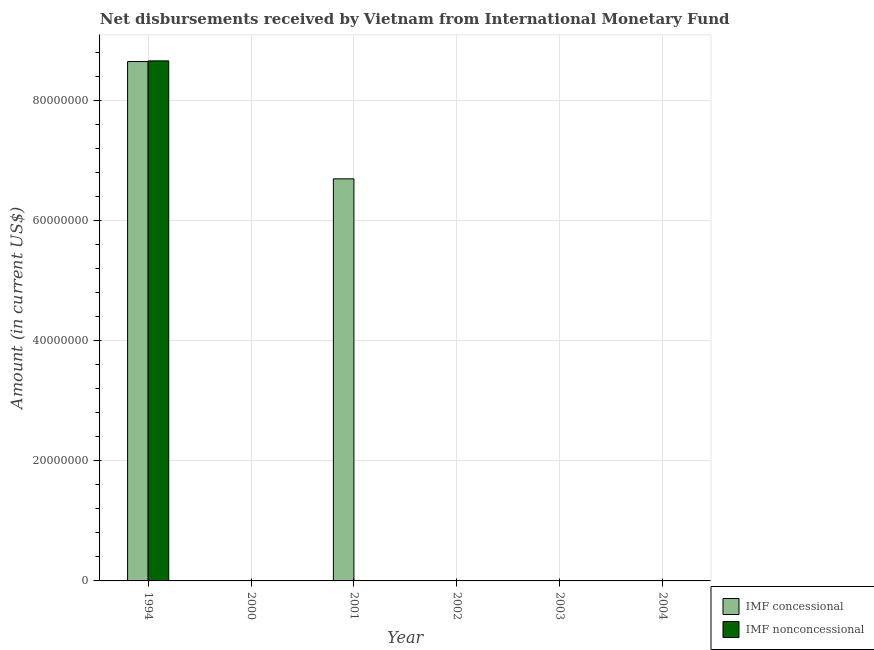How many different coloured bars are there?
Give a very brief answer. 2. Are the number of bars on each tick of the X-axis equal?
Ensure brevity in your answer.  No. How many bars are there on the 2nd tick from the left?
Provide a short and direct response. 0. What is the label of the 3rd group of bars from the left?
Your answer should be very brief. 2001. In how many cases, is the number of bars for a given year not equal to the number of legend labels?
Ensure brevity in your answer.  5. What is the net non concessional disbursements from imf in 1994?
Give a very brief answer. 8.66e+07. Across all years, what is the maximum net non concessional disbursements from imf?
Provide a succinct answer. 8.66e+07. In which year was the net concessional disbursements from imf maximum?
Your answer should be very brief. 1994. What is the total net concessional disbursements from imf in the graph?
Provide a short and direct response. 1.53e+08. What is the average net concessional disbursements from imf per year?
Offer a terse response. 2.56e+07. In how many years, is the net concessional disbursements from imf greater than 60000000 US$?
Give a very brief answer. 2. What is the difference between the highest and the lowest net concessional disbursements from imf?
Offer a very short reply. 8.65e+07. Are the values on the major ticks of Y-axis written in scientific E-notation?
Provide a succinct answer. No. Does the graph contain grids?
Your answer should be compact. Yes. Where does the legend appear in the graph?
Provide a short and direct response. Bottom right. How are the legend labels stacked?
Offer a very short reply. Vertical. What is the title of the graph?
Provide a succinct answer. Net disbursements received by Vietnam from International Monetary Fund. What is the label or title of the Y-axis?
Provide a succinct answer. Amount (in current US$). What is the Amount (in current US$) in IMF concessional in 1994?
Ensure brevity in your answer.  8.65e+07. What is the Amount (in current US$) in IMF nonconcessional in 1994?
Provide a succinct answer. 8.66e+07. What is the Amount (in current US$) of IMF concessional in 2000?
Provide a short and direct response. 0. What is the Amount (in current US$) of IMF concessional in 2001?
Your answer should be compact. 6.70e+07. What is the Amount (in current US$) in IMF nonconcessional in 2001?
Keep it short and to the point. 0. What is the Amount (in current US$) in IMF concessional in 2002?
Offer a terse response. 0. What is the Amount (in current US$) in IMF nonconcessional in 2002?
Your answer should be very brief. 0. What is the Amount (in current US$) of IMF concessional in 2003?
Keep it short and to the point. 0. What is the Amount (in current US$) of IMF nonconcessional in 2004?
Ensure brevity in your answer.  0. Across all years, what is the maximum Amount (in current US$) in IMF concessional?
Provide a short and direct response. 8.65e+07. Across all years, what is the maximum Amount (in current US$) in IMF nonconcessional?
Provide a short and direct response. 8.66e+07. Across all years, what is the minimum Amount (in current US$) in IMF nonconcessional?
Provide a short and direct response. 0. What is the total Amount (in current US$) in IMF concessional in the graph?
Offer a terse response. 1.53e+08. What is the total Amount (in current US$) of IMF nonconcessional in the graph?
Keep it short and to the point. 8.66e+07. What is the difference between the Amount (in current US$) in IMF concessional in 1994 and that in 2001?
Keep it short and to the point. 1.95e+07. What is the average Amount (in current US$) of IMF concessional per year?
Make the answer very short. 2.56e+07. What is the average Amount (in current US$) of IMF nonconcessional per year?
Your answer should be very brief. 1.44e+07. In the year 1994, what is the difference between the Amount (in current US$) of IMF concessional and Amount (in current US$) of IMF nonconcessional?
Ensure brevity in your answer.  -1.14e+05. What is the ratio of the Amount (in current US$) in IMF concessional in 1994 to that in 2001?
Ensure brevity in your answer.  1.29. What is the difference between the highest and the lowest Amount (in current US$) of IMF concessional?
Your answer should be compact. 8.65e+07. What is the difference between the highest and the lowest Amount (in current US$) in IMF nonconcessional?
Keep it short and to the point. 8.66e+07. 